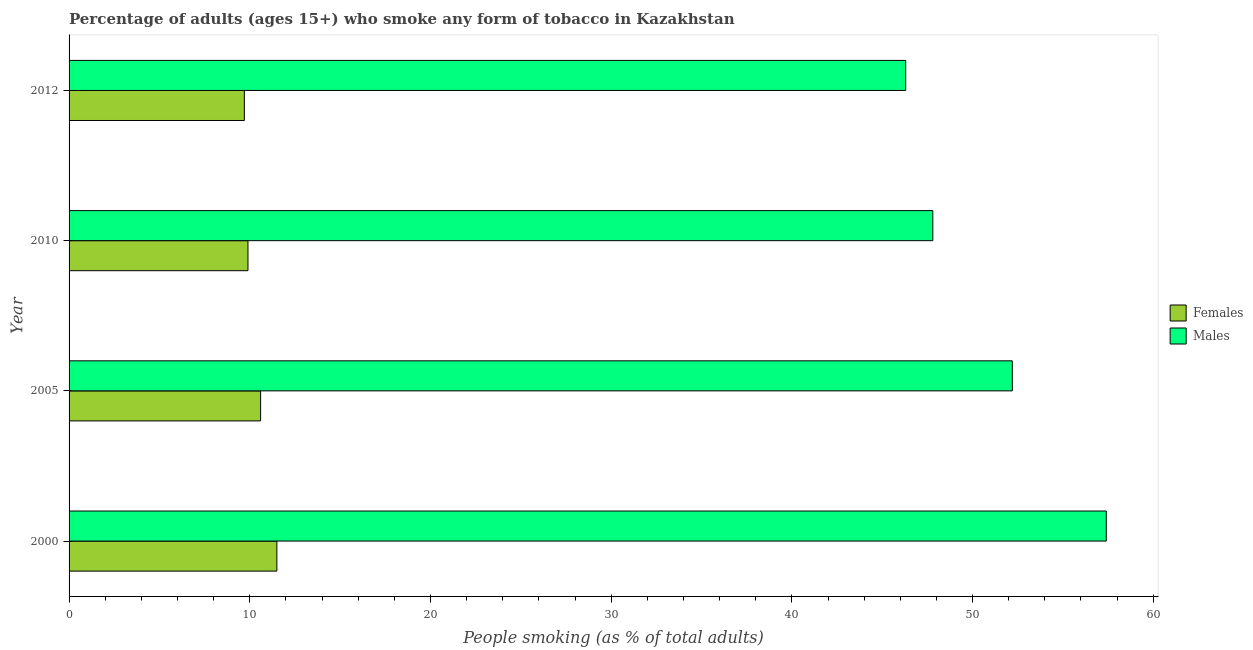Are the number of bars per tick equal to the number of legend labels?
Keep it short and to the point. Yes. What is the label of the 2nd group of bars from the top?
Your response must be concise. 2010. In how many cases, is the number of bars for a given year not equal to the number of legend labels?
Offer a terse response. 0. What is the percentage of males who smoke in 2010?
Offer a terse response. 47.8. Across all years, what is the maximum percentage of males who smoke?
Your response must be concise. 57.4. In which year was the percentage of males who smoke maximum?
Your answer should be compact. 2000. In which year was the percentage of males who smoke minimum?
Your response must be concise. 2012. What is the total percentage of males who smoke in the graph?
Provide a succinct answer. 203.7. What is the difference between the percentage of females who smoke in 2000 and that in 2005?
Offer a very short reply. 0.9. What is the difference between the percentage of males who smoke in 2010 and the percentage of females who smoke in 2005?
Your response must be concise. 37.2. What is the average percentage of males who smoke per year?
Offer a very short reply. 50.92. In the year 2012, what is the difference between the percentage of females who smoke and percentage of males who smoke?
Keep it short and to the point. -36.6. In how many years, is the percentage of females who smoke greater than 22 %?
Offer a terse response. 0. What is the ratio of the percentage of females who smoke in 2005 to that in 2012?
Keep it short and to the point. 1.09. Is the percentage of males who smoke in 2000 less than that in 2005?
Your response must be concise. No. Is the difference between the percentage of females who smoke in 2000 and 2010 greater than the difference between the percentage of males who smoke in 2000 and 2010?
Provide a short and direct response. No. What is the difference between the highest and the lowest percentage of females who smoke?
Provide a succinct answer. 1.8. In how many years, is the percentage of females who smoke greater than the average percentage of females who smoke taken over all years?
Your answer should be compact. 2. What does the 1st bar from the top in 2012 represents?
Make the answer very short. Males. What does the 1st bar from the bottom in 2012 represents?
Provide a succinct answer. Females. Are all the bars in the graph horizontal?
Make the answer very short. Yes. Are the values on the major ticks of X-axis written in scientific E-notation?
Keep it short and to the point. No. Does the graph contain any zero values?
Provide a short and direct response. No. Does the graph contain grids?
Your answer should be compact. No. Where does the legend appear in the graph?
Provide a succinct answer. Center right. How many legend labels are there?
Provide a short and direct response. 2. How are the legend labels stacked?
Your answer should be compact. Vertical. What is the title of the graph?
Provide a succinct answer. Percentage of adults (ages 15+) who smoke any form of tobacco in Kazakhstan. Does "Commercial service imports" appear as one of the legend labels in the graph?
Offer a terse response. No. What is the label or title of the X-axis?
Keep it short and to the point. People smoking (as % of total adults). What is the People smoking (as % of total adults) in Females in 2000?
Keep it short and to the point. 11.5. What is the People smoking (as % of total adults) in Males in 2000?
Give a very brief answer. 57.4. What is the People smoking (as % of total adults) in Males in 2005?
Provide a short and direct response. 52.2. What is the People smoking (as % of total adults) in Males in 2010?
Provide a short and direct response. 47.8. What is the People smoking (as % of total adults) of Males in 2012?
Give a very brief answer. 46.3. Across all years, what is the maximum People smoking (as % of total adults) in Females?
Make the answer very short. 11.5. Across all years, what is the maximum People smoking (as % of total adults) in Males?
Your response must be concise. 57.4. Across all years, what is the minimum People smoking (as % of total adults) in Males?
Your answer should be compact. 46.3. What is the total People smoking (as % of total adults) of Females in the graph?
Your response must be concise. 41.7. What is the total People smoking (as % of total adults) of Males in the graph?
Offer a terse response. 203.7. What is the difference between the People smoking (as % of total adults) in Females in 2000 and that in 2005?
Ensure brevity in your answer.  0.9. What is the difference between the People smoking (as % of total adults) in Females in 2000 and that in 2010?
Offer a terse response. 1.6. What is the difference between the People smoking (as % of total adults) in Females in 2000 and that in 2012?
Provide a succinct answer. 1.8. What is the difference between the People smoking (as % of total adults) in Males in 2000 and that in 2012?
Your answer should be compact. 11.1. What is the difference between the People smoking (as % of total adults) in Males in 2005 and that in 2010?
Your answer should be compact. 4.4. What is the difference between the People smoking (as % of total adults) of Males in 2005 and that in 2012?
Your response must be concise. 5.9. What is the difference between the People smoking (as % of total adults) of Females in 2010 and that in 2012?
Offer a terse response. 0.2. What is the difference between the People smoking (as % of total adults) of Females in 2000 and the People smoking (as % of total adults) of Males in 2005?
Make the answer very short. -40.7. What is the difference between the People smoking (as % of total adults) in Females in 2000 and the People smoking (as % of total adults) in Males in 2010?
Provide a succinct answer. -36.3. What is the difference between the People smoking (as % of total adults) of Females in 2000 and the People smoking (as % of total adults) of Males in 2012?
Ensure brevity in your answer.  -34.8. What is the difference between the People smoking (as % of total adults) in Females in 2005 and the People smoking (as % of total adults) in Males in 2010?
Provide a succinct answer. -37.2. What is the difference between the People smoking (as % of total adults) in Females in 2005 and the People smoking (as % of total adults) in Males in 2012?
Your answer should be very brief. -35.7. What is the difference between the People smoking (as % of total adults) in Females in 2010 and the People smoking (as % of total adults) in Males in 2012?
Offer a very short reply. -36.4. What is the average People smoking (as % of total adults) in Females per year?
Give a very brief answer. 10.43. What is the average People smoking (as % of total adults) in Males per year?
Give a very brief answer. 50.92. In the year 2000, what is the difference between the People smoking (as % of total adults) of Females and People smoking (as % of total adults) of Males?
Your answer should be very brief. -45.9. In the year 2005, what is the difference between the People smoking (as % of total adults) of Females and People smoking (as % of total adults) of Males?
Provide a short and direct response. -41.6. In the year 2010, what is the difference between the People smoking (as % of total adults) of Females and People smoking (as % of total adults) of Males?
Provide a short and direct response. -37.9. In the year 2012, what is the difference between the People smoking (as % of total adults) of Females and People smoking (as % of total adults) of Males?
Your answer should be very brief. -36.6. What is the ratio of the People smoking (as % of total adults) in Females in 2000 to that in 2005?
Offer a terse response. 1.08. What is the ratio of the People smoking (as % of total adults) of Males in 2000 to that in 2005?
Your answer should be compact. 1.1. What is the ratio of the People smoking (as % of total adults) of Females in 2000 to that in 2010?
Keep it short and to the point. 1.16. What is the ratio of the People smoking (as % of total adults) in Males in 2000 to that in 2010?
Offer a very short reply. 1.2. What is the ratio of the People smoking (as % of total adults) of Females in 2000 to that in 2012?
Your answer should be very brief. 1.19. What is the ratio of the People smoking (as % of total adults) of Males in 2000 to that in 2012?
Your response must be concise. 1.24. What is the ratio of the People smoking (as % of total adults) of Females in 2005 to that in 2010?
Offer a very short reply. 1.07. What is the ratio of the People smoking (as % of total adults) in Males in 2005 to that in 2010?
Offer a terse response. 1.09. What is the ratio of the People smoking (as % of total adults) of Females in 2005 to that in 2012?
Your response must be concise. 1.09. What is the ratio of the People smoking (as % of total adults) in Males in 2005 to that in 2012?
Keep it short and to the point. 1.13. What is the ratio of the People smoking (as % of total adults) in Females in 2010 to that in 2012?
Ensure brevity in your answer.  1.02. What is the ratio of the People smoking (as % of total adults) of Males in 2010 to that in 2012?
Offer a terse response. 1.03. What is the difference between the highest and the second highest People smoking (as % of total adults) in Males?
Provide a short and direct response. 5.2. 